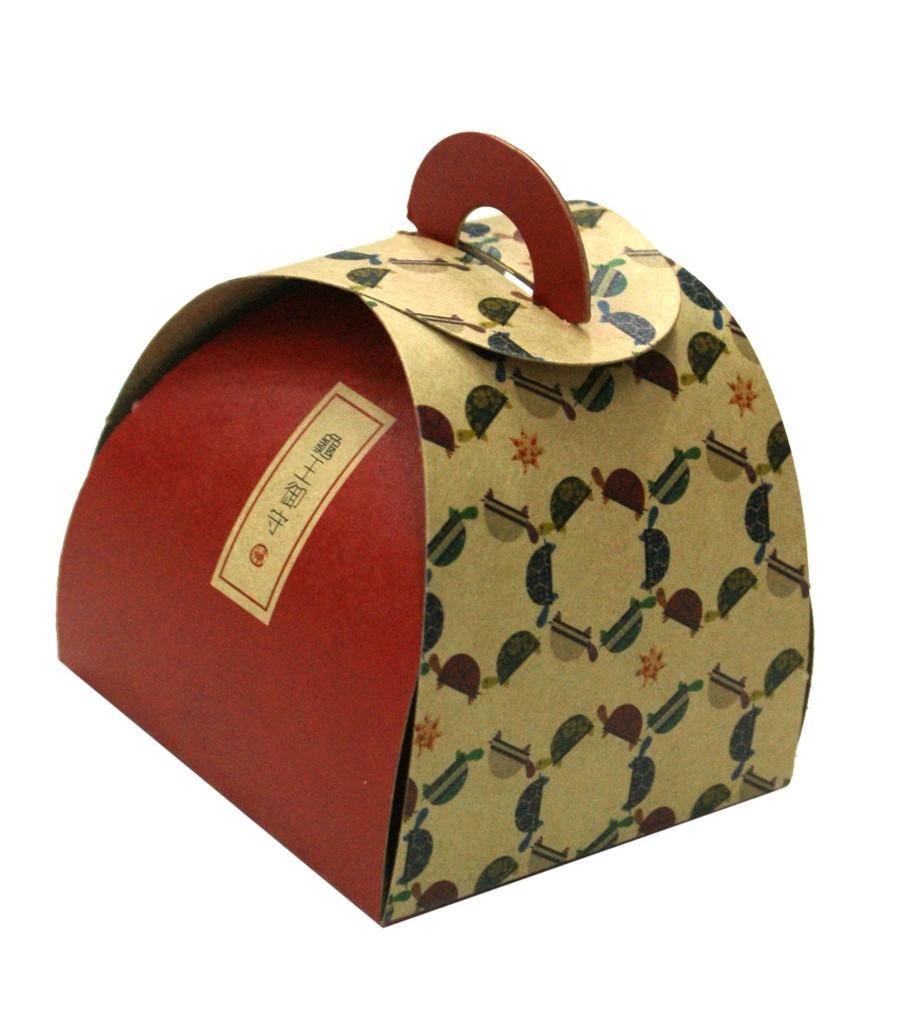What object is present in the image related to gift giving? There is a gift packing box in the image. What feature does the gift packing box have for easy carrying? The gift packing box has a handle. What type of fiction is being read by the person in the image? There is no person present in the image, and therefore no one is reading any fiction. 